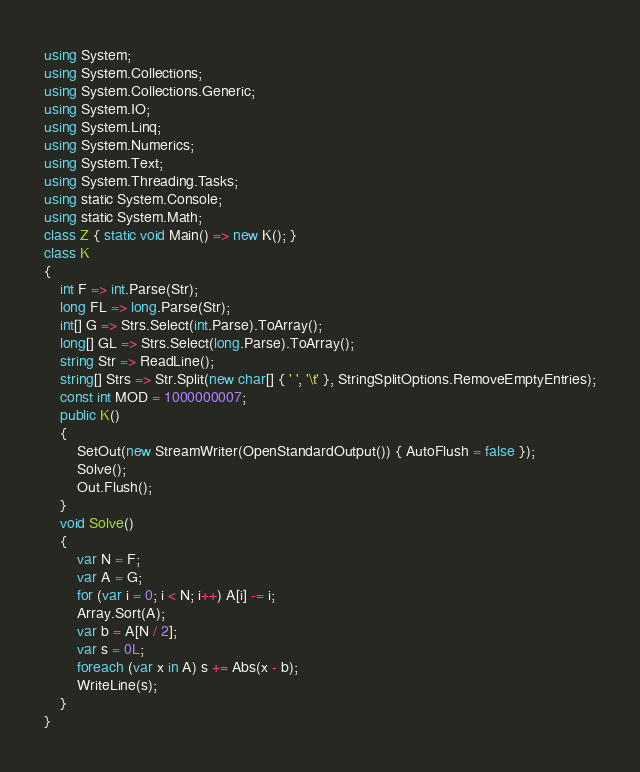<code> <loc_0><loc_0><loc_500><loc_500><_C#_>using System;
using System.Collections;
using System.Collections.Generic;
using System.IO;
using System.Linq;
using System.Numerics;
using System.Text;
using System.Threading.Tasks;
using static System.Console;
using static System.Math;
class Z { static void Main() => new K(); }
class K
{
	int F => int.Parse(Str);
	long FL => long.Parse(Str);
	int[] G => Strs.Select(int.Parse).ToArray();
	long[] GL => Strs.Select(long.Parse).ToArray();
	string Str => ReadLine();
	string[] Strs => Str.Split(new char[] { ' ', '\t' }, StringSplitOptions.RemoveEmptyEntries);
	const int MOD = 1000000007;
	public K()
	{
		SetOut(new StreamWriter(OpenStandardOutput()) { AutoFlush = false });
		Solve();
		Out.Flush();
	}
	void Solve()
	{
		var N = F;
		var A = G;
		for (var i = 0; i < N; i++) A[i] -= i;
		Array.Sort(A);
		var b = A[N / 2];
		var s = 0L;
		foreach (var x in A) s += Abs(x - b);
		WriteLine(s);
	}
}
</code> 